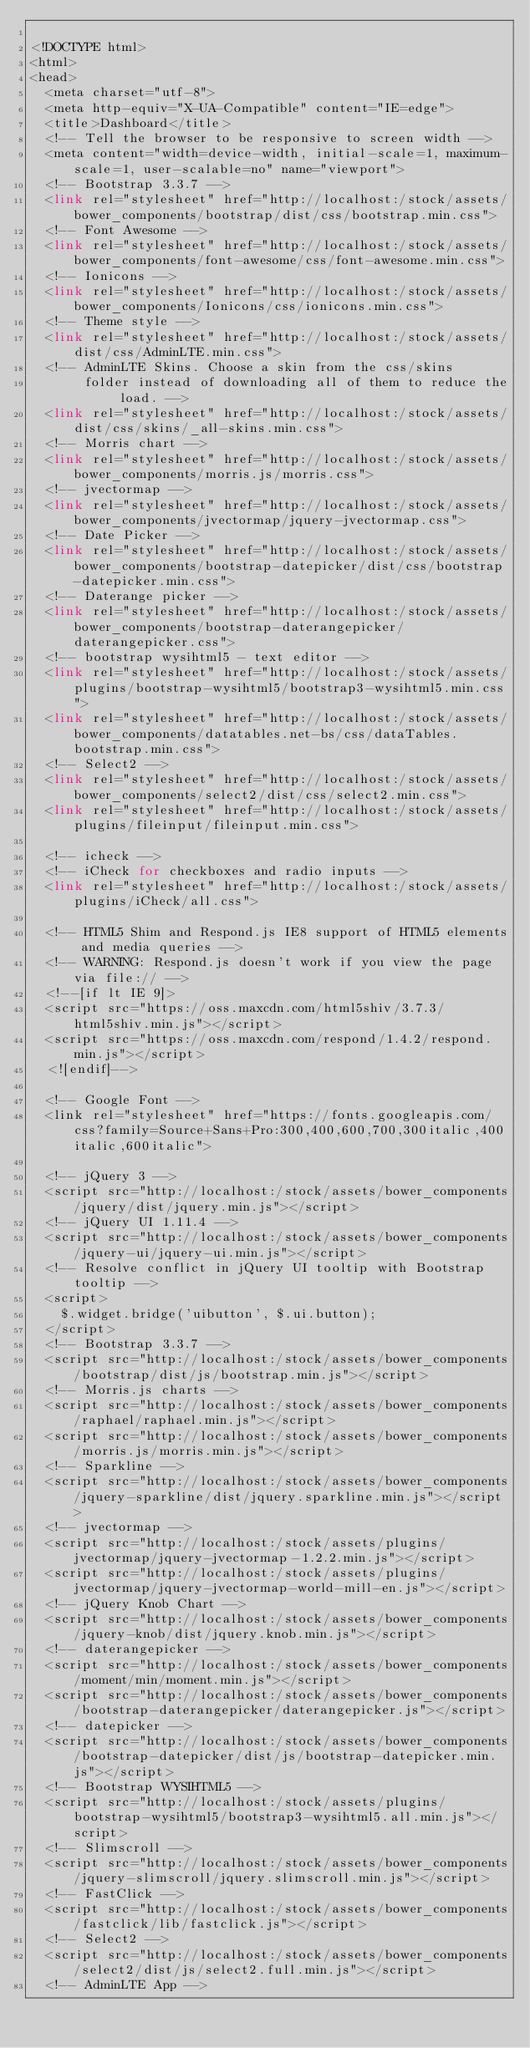Convert code to text. <code><loc_0><loc_0><loc_500><loc_500><_PHP_>
<!DOCTYPE html>
<html>
<head>
  <meta charset="utf-8">
  <meta http-equiv="X-UA-Compatible" content="IE=edge">
  <title>Dashboard</title>
  <!-- Tell the browser to be responsive to screen width -->
  <meta content="width=device-width, initial-scale=1, maximum-scale=1, user-scalable=no" name="viewport">
  <!-- Bootstrap 3.3.7 -->  
  <link rel="stylesheet" href="http://localhost:/stock/assets/bower_components/bootstrap/dist/css/bootstrap.min.css">
  <!-- Font Awesome -->  
  <link rel="stylesheet" href="http://localhost:/stock/assets/bower_components/font-awesome/css/font-awesome.min.css">
  <!-- Ionicons -->
  <link rel="stylesheet" href="http://localhost:/stock/assets/bower_components/Ionicons/css/ionicons.min.css">
  <!-- Theme style -->
  <link rel="stylesheet" href="http://localhost:/stock/assets/dist/css/AdminLTE.min.css">
  <!-- AdminLTE Skins. Choose a skin from the css/skins
       folder instead of downloading all of them to reduce the load. -->
  <link rel="stylesheet" href="http://localhost:/stock/assets/dist/css/skins/_all-skins.min.css">
  <!-- Morris chart -->
  <link rel="stylesheet" href="http://localhost:/stock/assets/bower_components/morris.js/morris.css">
  <!-- jvectormap -->
  <link rel="stylesheet" href="http://localhost:/stock/assets/bower_components/jvectormap/jquery-jvectormap.css">
  <!-- Date Picker -->
  <link rel="stylesheet" href="http://localhost:/stock/assets/bower_components/bootstrap-datepicker/dist/css/bootstrap-datepicker.min.css">
  <!-- Daterange picker -->  
  <link rel="stylesheet" href="http://localhost:/stock/assets/bower_components/bootstrap-daterangepicker/daterangepicker.css">
  <!-- bootstrap wysihtml5 - text editor -->
  <link rel="stylesheet" href="http://localhost:/stock/assets/plugins/bootstrap-wysihtml5/bootstrap3-wysihtml5.min.css">
  <link rel="stylesheet" href="http://localhost:/stock/assets/bower_components/datatables.net-bs/css/dataTables.bootstrap.min.css">
  <!-- Select2 -->
  <link rel="stylesheet" href="http://localhost:/stock/assets/bower_components/select2/dist/css/select2.min.css">
  <link rel="stylesheet" href="http://localhost:/stock/assets/plugins/fileinput/fileinput.min.css">

  <!-- icheck -->
  <!-- iCheck for checkboxes and radio inputs -->
  <link rel="stylesheet" href="http://localhost:/stock/assets/plugins/iCheck/all.css">

  <!-- HTML5 Shim and Respond.js IE8 support of HTML5 elements and media queries -->
  <!-- WARNING: Respond.js doesn't work if you view the page via file:// -->
  <!--[if lt IE 9]>
  <script src="https://oss.maxcdn.com/html5shiv/3.7.3/html5shiv.min.js"></script>
  <script src="https://oss.maxcdn.com/respond/1.4.2/respond.min.js"></script>
  <![endif]-->

  <!-- Google Font -->
  <link rel="stylesheet" href="https://fonts.googleapis.com/css?family=Source+Sans+Pro:300,400,600,700,300italic,400italic,600italic">

  <!-- jQuery 3 -->
  <script src="http://localhost:/stock/assets/bower_components/jquery/dist/jquery.min.js"></script>
  <!-- jQuery UI 1.11.4 -->
  <script src="http://localhost:/stock/assets/bower_components/jquery-ui/jquery-ui.min.js"></script>
  <!-- Resolve conflict in jQuery UI tooltip with Bootstrap tooltip -->
  <script>
    $.widget.bridge('uibutton', $.ui.button);
  </script>
  <!-- Bootstrap 3.3.7 -->
  <script src="http://localhost:/stock/assets/bower_components/bootstrap/dist/js/bootstrap.min.js"></script>
  <!-- Morris.js charts -->
  <script src="http://localhost:/stock/assets/bower_components/raphael/raphael.min.js"></script>
  <script src="http://localhost:/stock/assets/bower_components/morris.js/morris.min.js"></script>
  <!-- Sparkline -->
  <script src="http://localhost:/stock/assets/bower_components/jquery-sparkline/dist/jquery.sparkline.min.js"></script>
  <!-- jvectormap -->
  <script src="http://localhost:/stock/assets/plugins/jvectormap/jquery-jvectormap-1.2.2.min.js"></script>
  <script src="http://localhost:/stock/assets/plugins/jvectormap/jquery-jvectormap-world-mill-en.js"></script>
  <!-- jQuery Knob Chart -->
  <script src="http://localhost:/stock/assets/bower_components/jquery-knob/dist/jquery.knob.min.js"></script>
  <!-- daterangepicker -->
  <script src="http://localhost:/stock/assets/bower_components/moment/min/moment.min.js"></script>
  <script src="http://localhost:/stock/assets/bower_components/bootstrap-daterangepicker/daterangepicker.js"></script>
  <!-- datepicker -->
  <script src="http://localhost:/stock/assets/bower_components/bootstrap-datepicker/dist/js/bootstrap-datepicker.min.js"></script>
  <!-- Bootstrap WYSIHTML5 -->
  <script src="http://localhost:/stock/assets/plugins/bootstrap-wysihtml5/bootstrap3-wysihtml5.all.min.js"></script>
  <!-- Slimscroll -->
  <script src="http://localhost:/stock/assets/bower_components/jquery-slimscroll/jquery.slimscroll.min.js"></script>
  <!-- FastClick -->
  <script src="http://localhost:/stock/assets/bower_components/fastclick/lib/fastclick.js"></script>
  <!-- Select2 -->
  <script src="http://localhost:/stock/assets/bower_components/select2/dist/js/select2.full.min.js"></script>
  <!-- AdminLTE App -->  </code> 